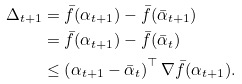<formula> <loc_0><loc_0><loc_500><loc_500>\Delta _ { t + 1 } & = \bar { f } ( \alpha _ { t + 1 } ) - \bar { f } ( \bar { \alpha } _ { t + 1 } ) \\ & = \bar { f } ( \alpha _ { t + 1 } ) - \bar { f } ( \bar { \alpha } _ { t } ) \\ & \leq \left ( \alpha _ { t + 1 } - \bar { \alpha } _ { t } \right ) ^ { \top } \nabla \bar { f } ( \alpha _ { t + 1 } ) .</formula> 